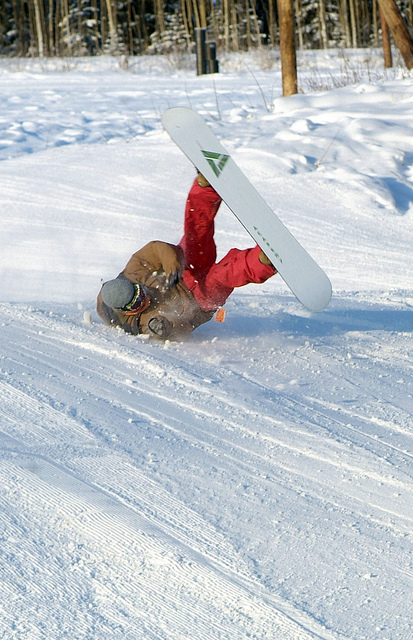<image>What symbol is on the bottom of the snowboard? I don't know what symbol is on the bottom of the snowboard. However, it might be a triangle according to some observations. What symbol is on the bottom of the snowboard? I don't know what symbol is on the bottom of the snowboard. It seems to be a triangle, but I am not certain. 